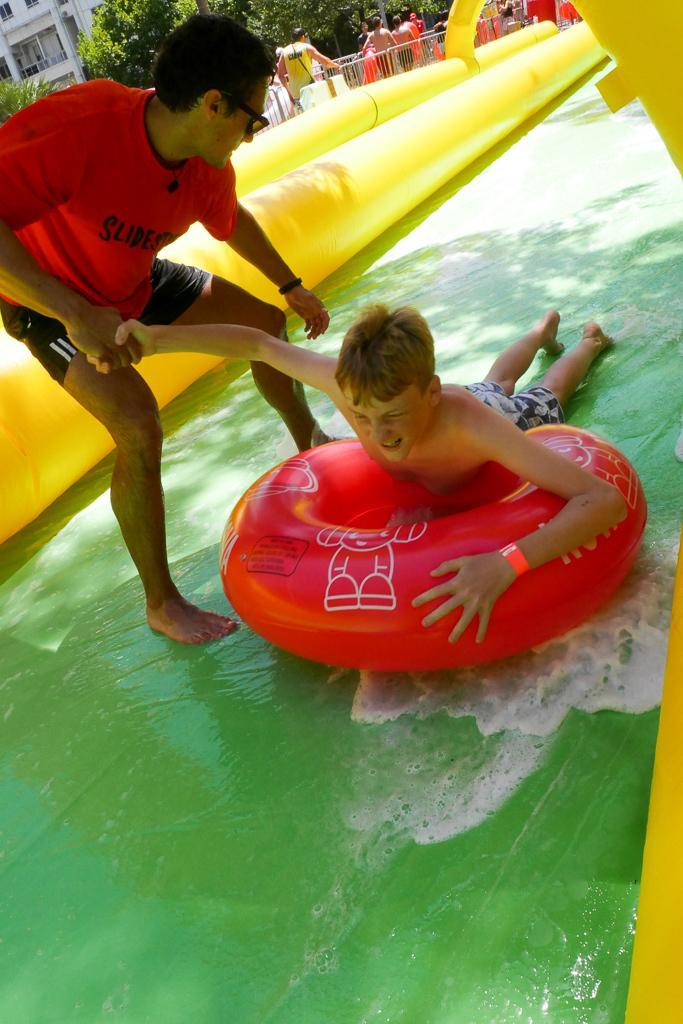Please provide a concise description of this image. In this image I can see a boy laying on balloon in the water and I can see a person standing on the water and holding a boy hand and I can see yellow color fence in the middle at the top I can see tree ,building and people. 